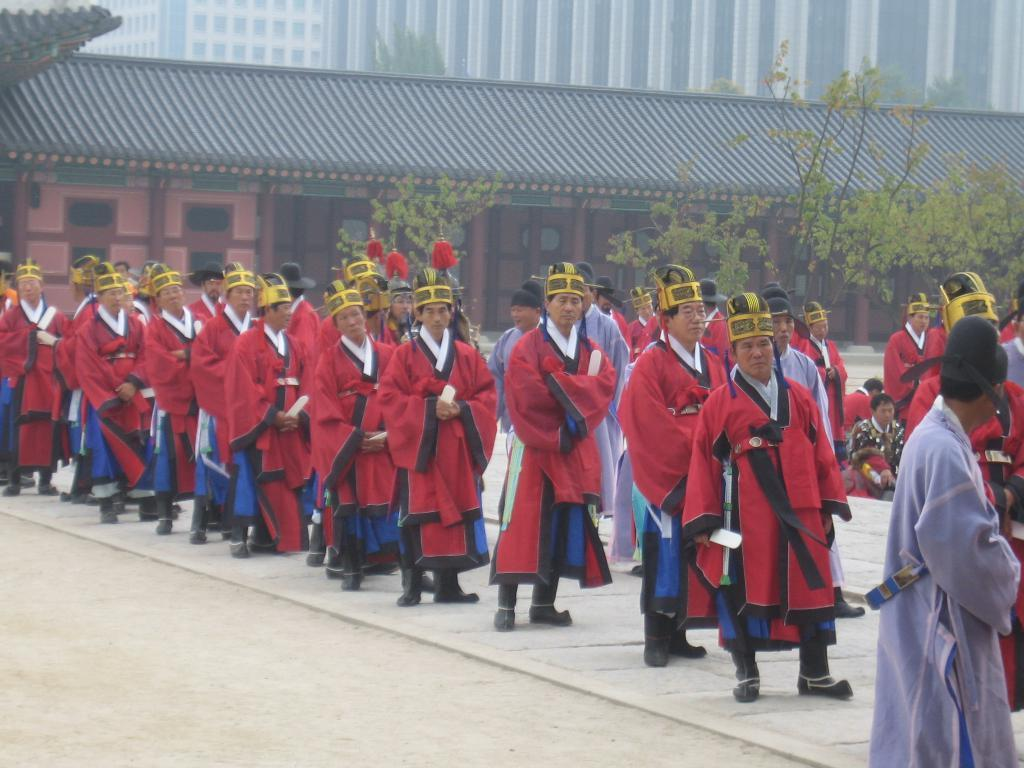How many people are in the image? There is a group of people standing in the image, and two people are sitting. What are the people in the image doing? The people are standing and sitting, but their specific actions are not clear from the image. What can be seen in the background of the image? There are buildings and trees in the background of the image. What is visible at the bottom of the image? There is a road visible at the bottom of the image. What type of music is the mom playing for the group in the image? There is no mom or music present in the image. Can you see a kiss between any of the people in the image? There is no kiss visible between any of the people in the image. 